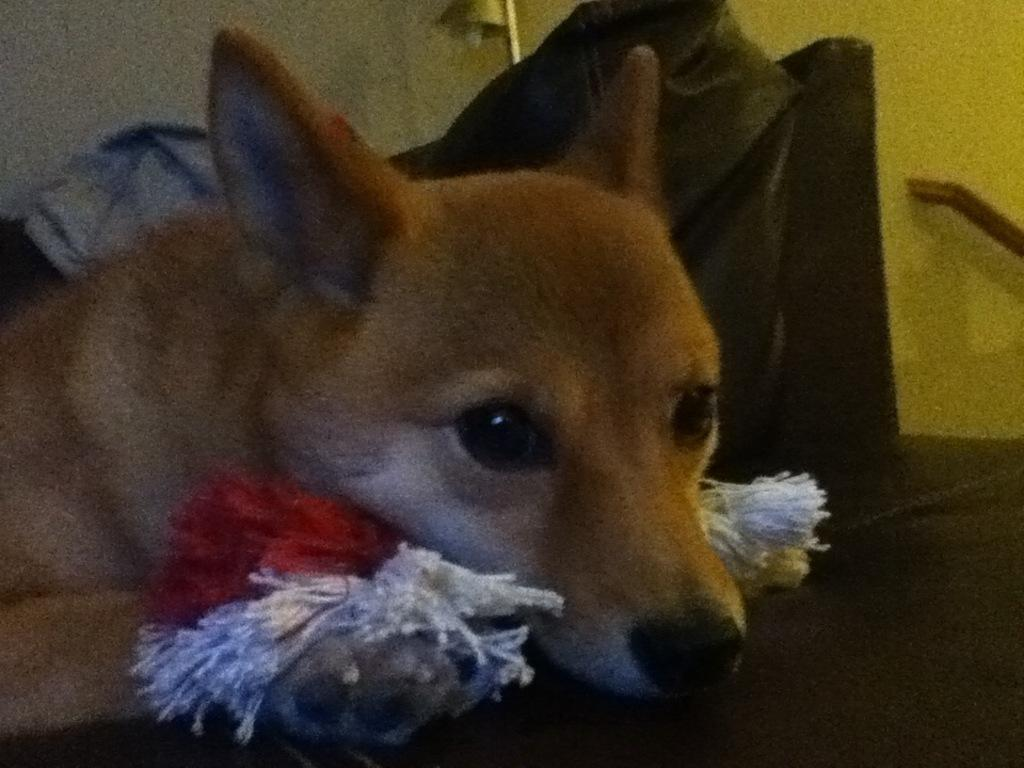What animal can be seen in the image? There is a dog in the image. What is the color of the surface the dog is on? The dog is on a black surface. What is the dog holding in its mouth? The dog has thread bundles in its mouth. What is the color of the object behind the dog? There is a black color object behind the dog. What type of lighting source is present in the image? There is a lamp in the image. What type of weather can be seen in the image? The image does not depict any weather conditions; it is an indoor scene with a dog, thread bundles, and a lamp. Is there a note attached to the dog in the image? There is no note present in the image. 